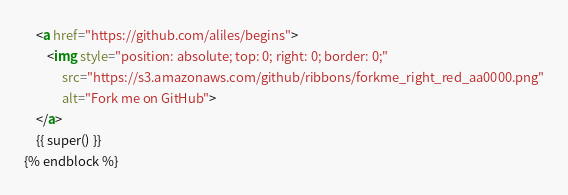Convert code to text. <code><loc_0><loc_0><loc_500><loc_500><_HTML_>    <a href="https://github.com/aliles/begins">
        <img style="position: absolute; top: 0; right: 0; border: 0;"
             src="https://s3.amazonaws.com/github/ribbons/forkme_right_red_aa0000.png"
             alt="Fork me on GitHub">
    </a>
    {{ super() }}
{% endblock %}
</code> 